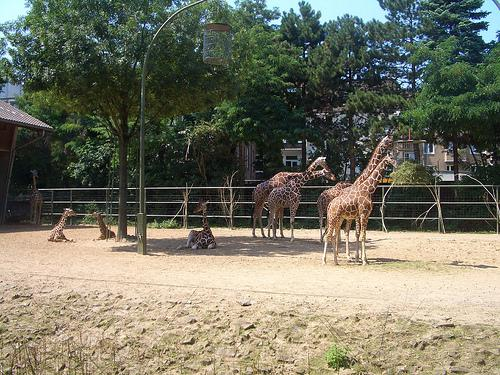Question: what are the giraffes standing on?
Choices:
A. Grass.
B. Dirt.
C. Gravel.
D. Mulch.
Answer with the letter. Answer: B Question: how is the day?
Choices:
A. Cloudy.
B. Partly cloudy.
C. Sunny.
D. Cold.
Answer with the letter. Answer: C Question: what are in the background?
Choices:
A. A tree.
B. A river.
C. A bridge.
D. Buildings.
Answer with the letter. Answer: D Question: how many bars high is the fence?
Choices:
A. Four.
B. Five.
C. Six.
D. Three.
Answer with the letter. Answer: D 